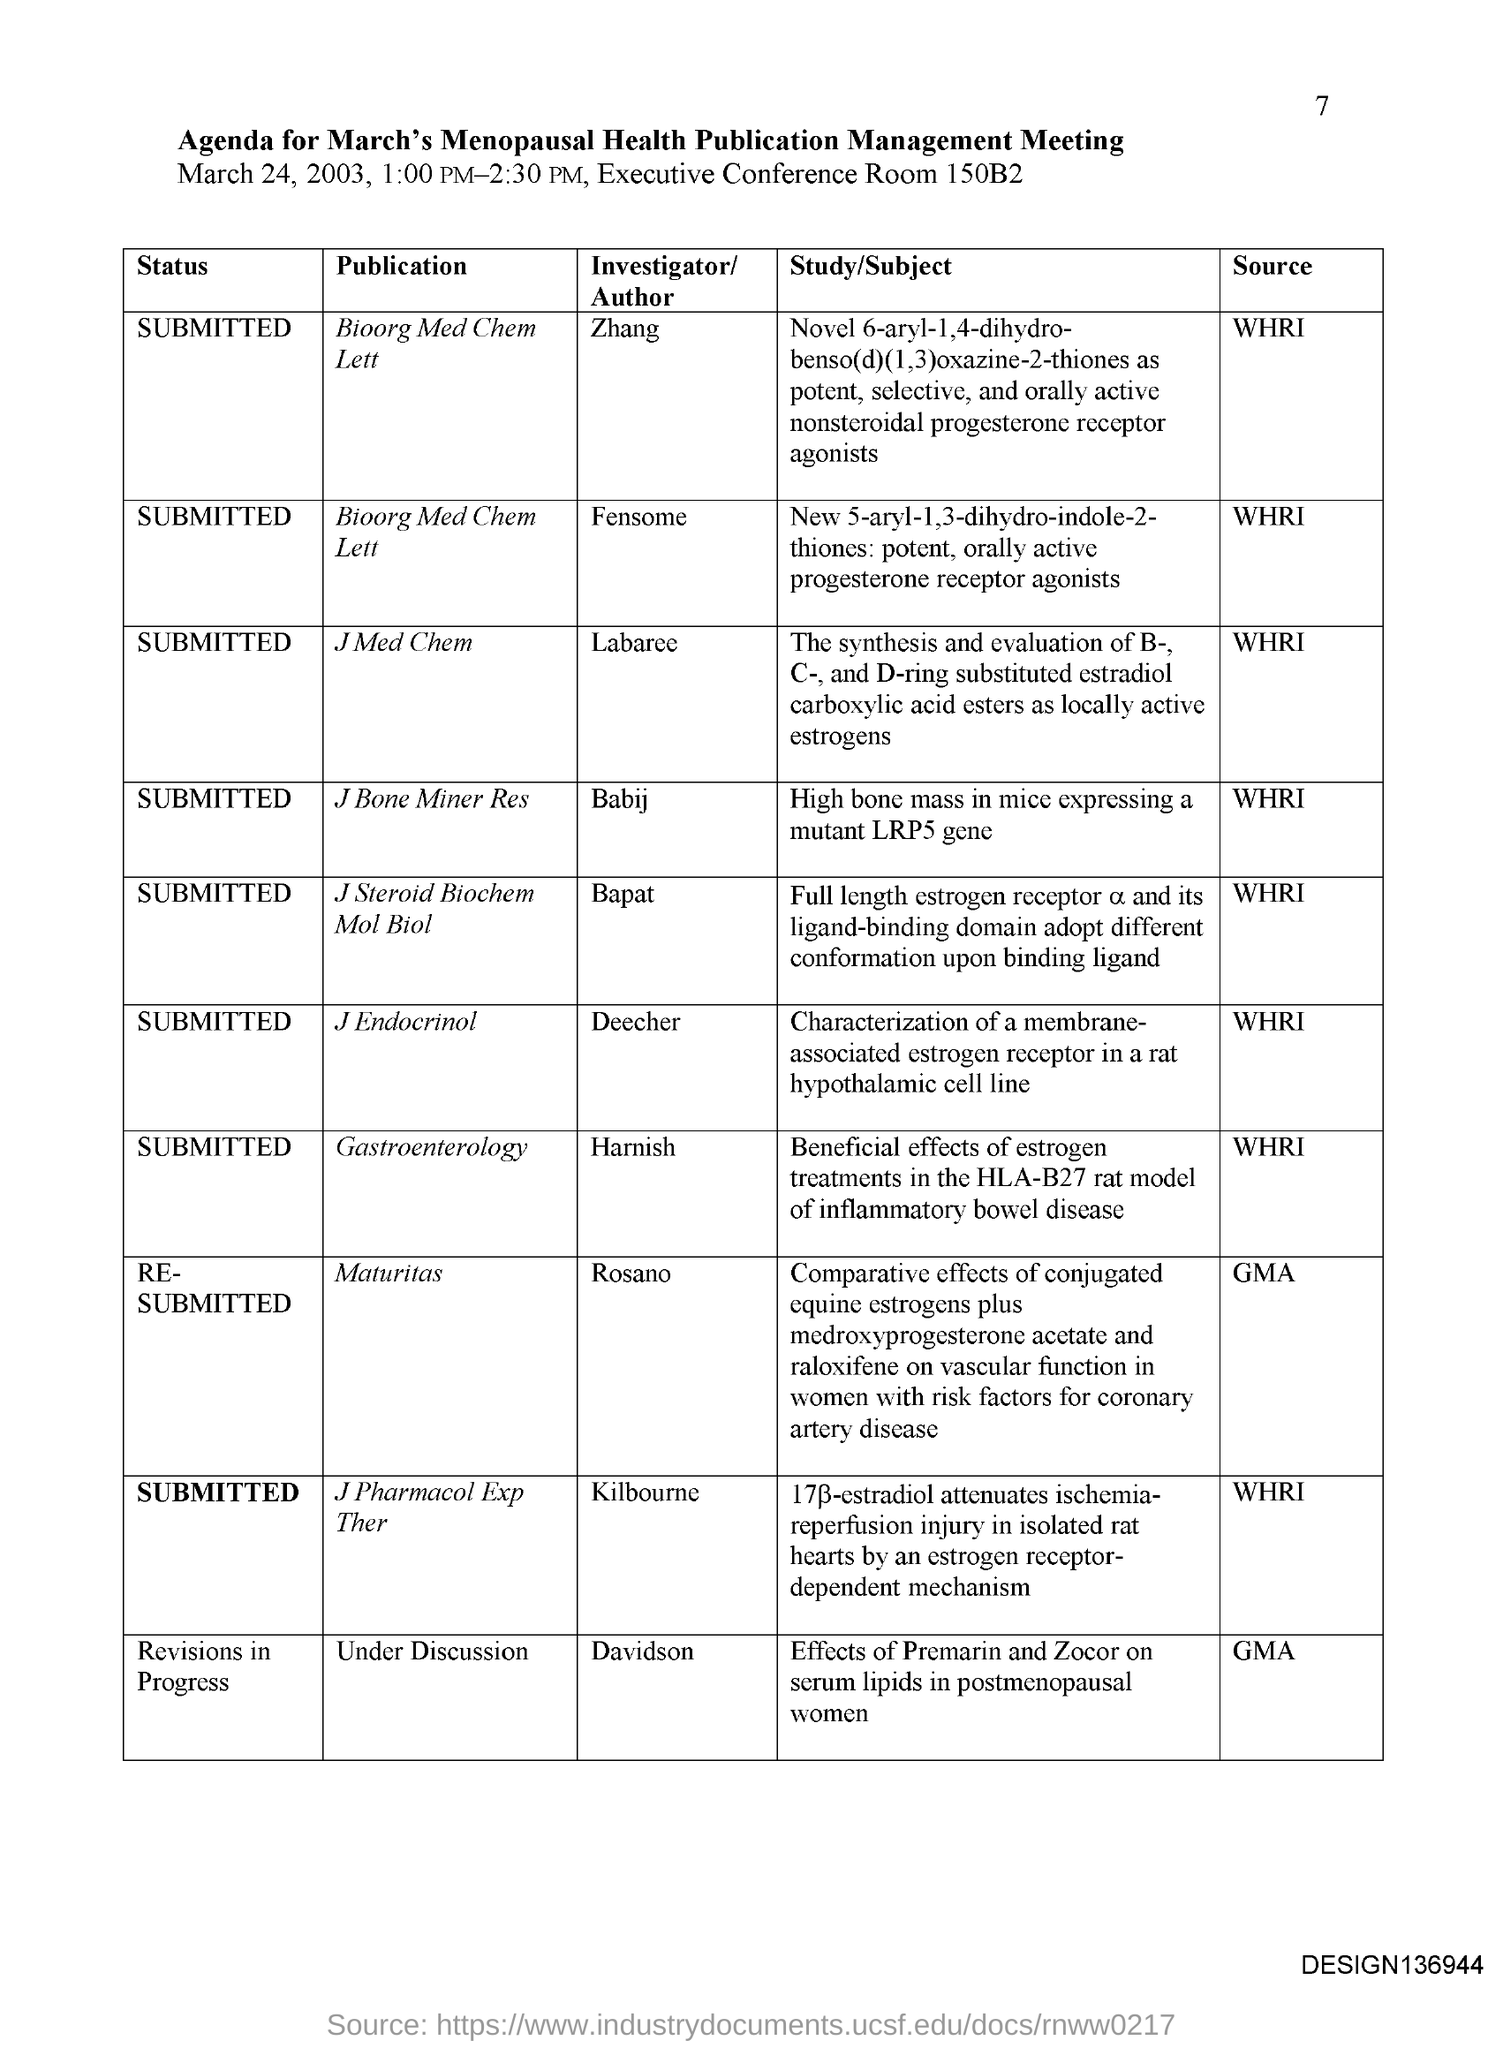What is WHRI, as mentioned in the source column? WHRI mentioned in the source column likely stands for the Women's Health Research Institute or a similarly named organization. It suggests that this entity is either funding, conducting, or has a significant interest in the outcomes of the research studies mentioned in the agenda. 